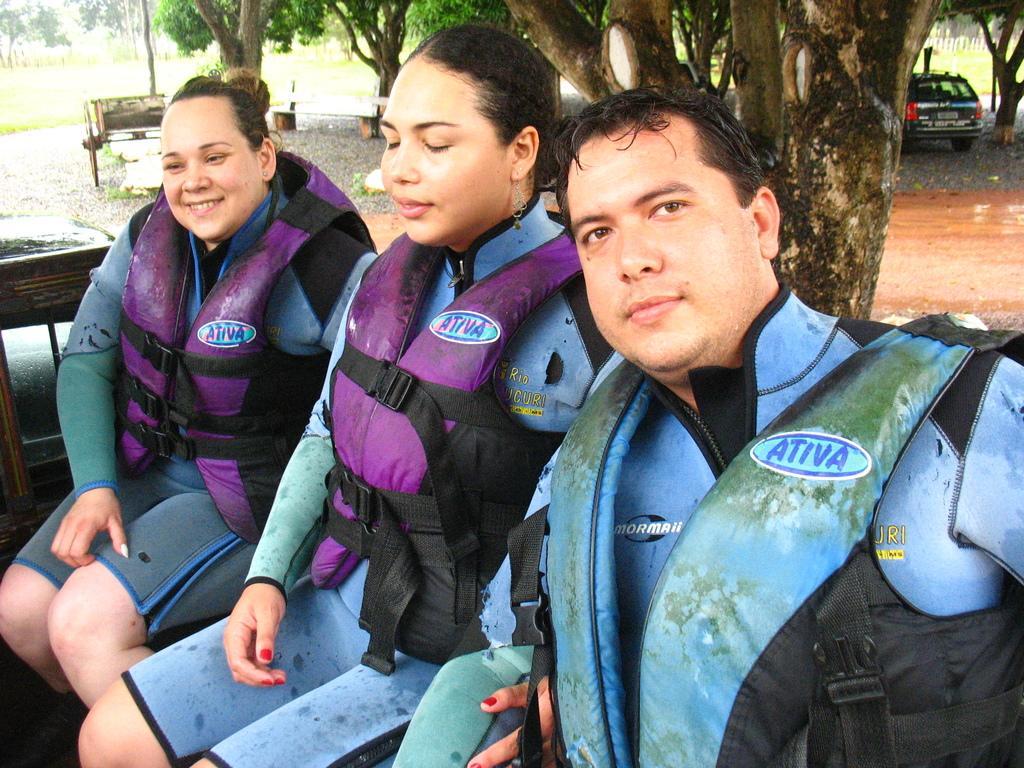Describe this image in one or two sentences. In this picture we can see a three people wearing jackets and sitting. We can see a few wooden objects, vehicle, the tree trunk and some trees are visible in the background. 